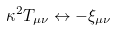<formula> <loc_0><loc_0><loc_500><loc_500>\kappa ^ { 2 } T _ { \mu \nu } \leftrightarrow - \xi _ { \mu \nu }</formula> 